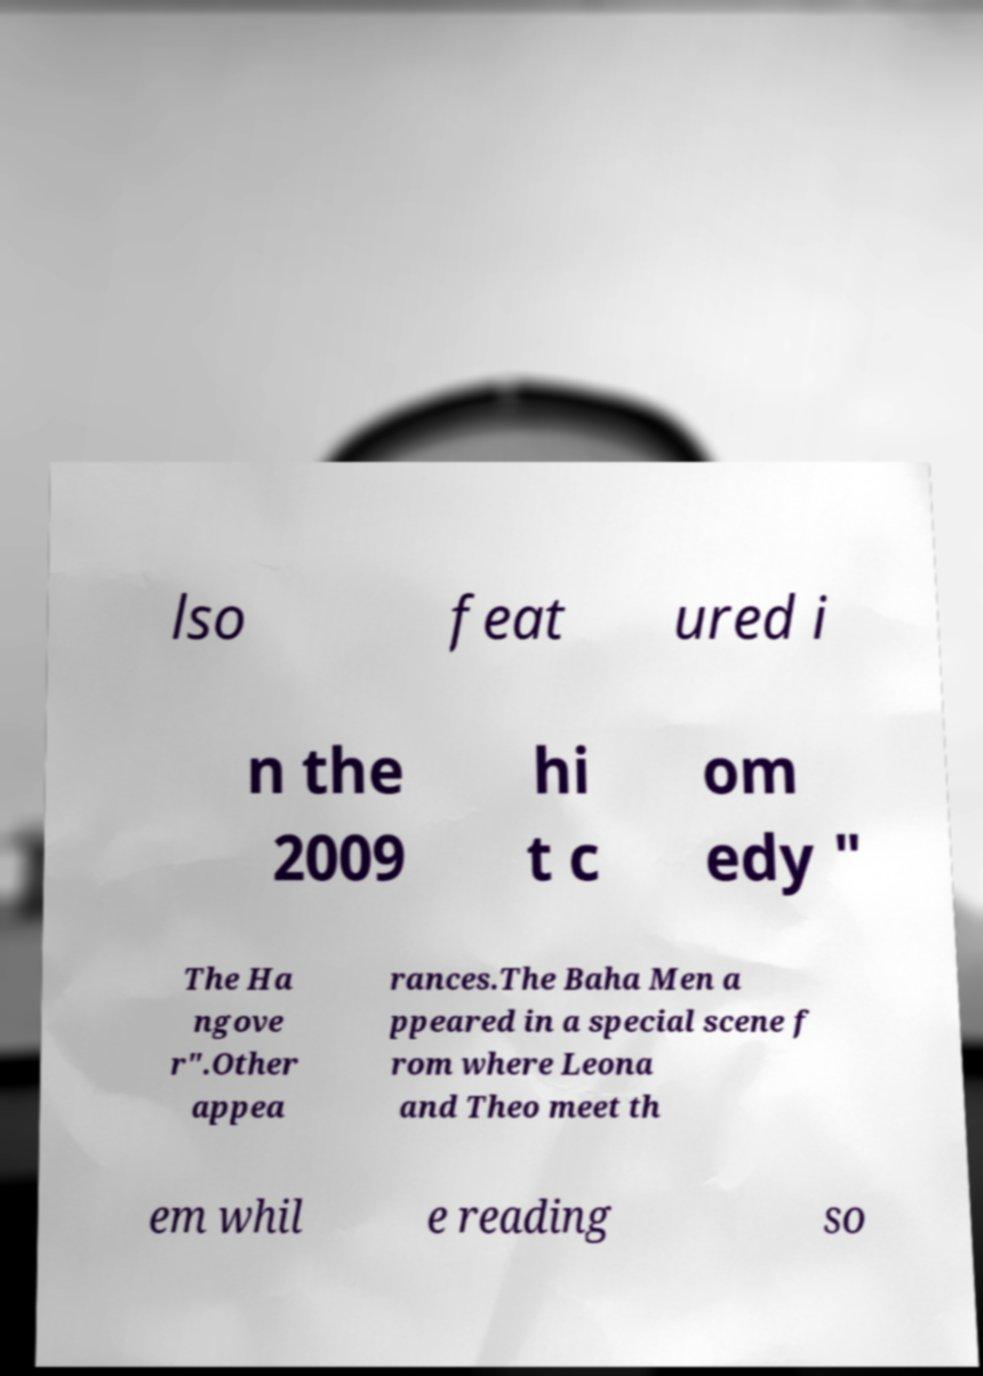Could you assist in decoding the text presented in this image and type it out clearly? lso feat ured i n the 2009 hi t c om edy " The Ha ngove r".Other appea rances.The Baha Men a ppeared in a special scene f rom where Leona and Theo meet th em whil e reading so 